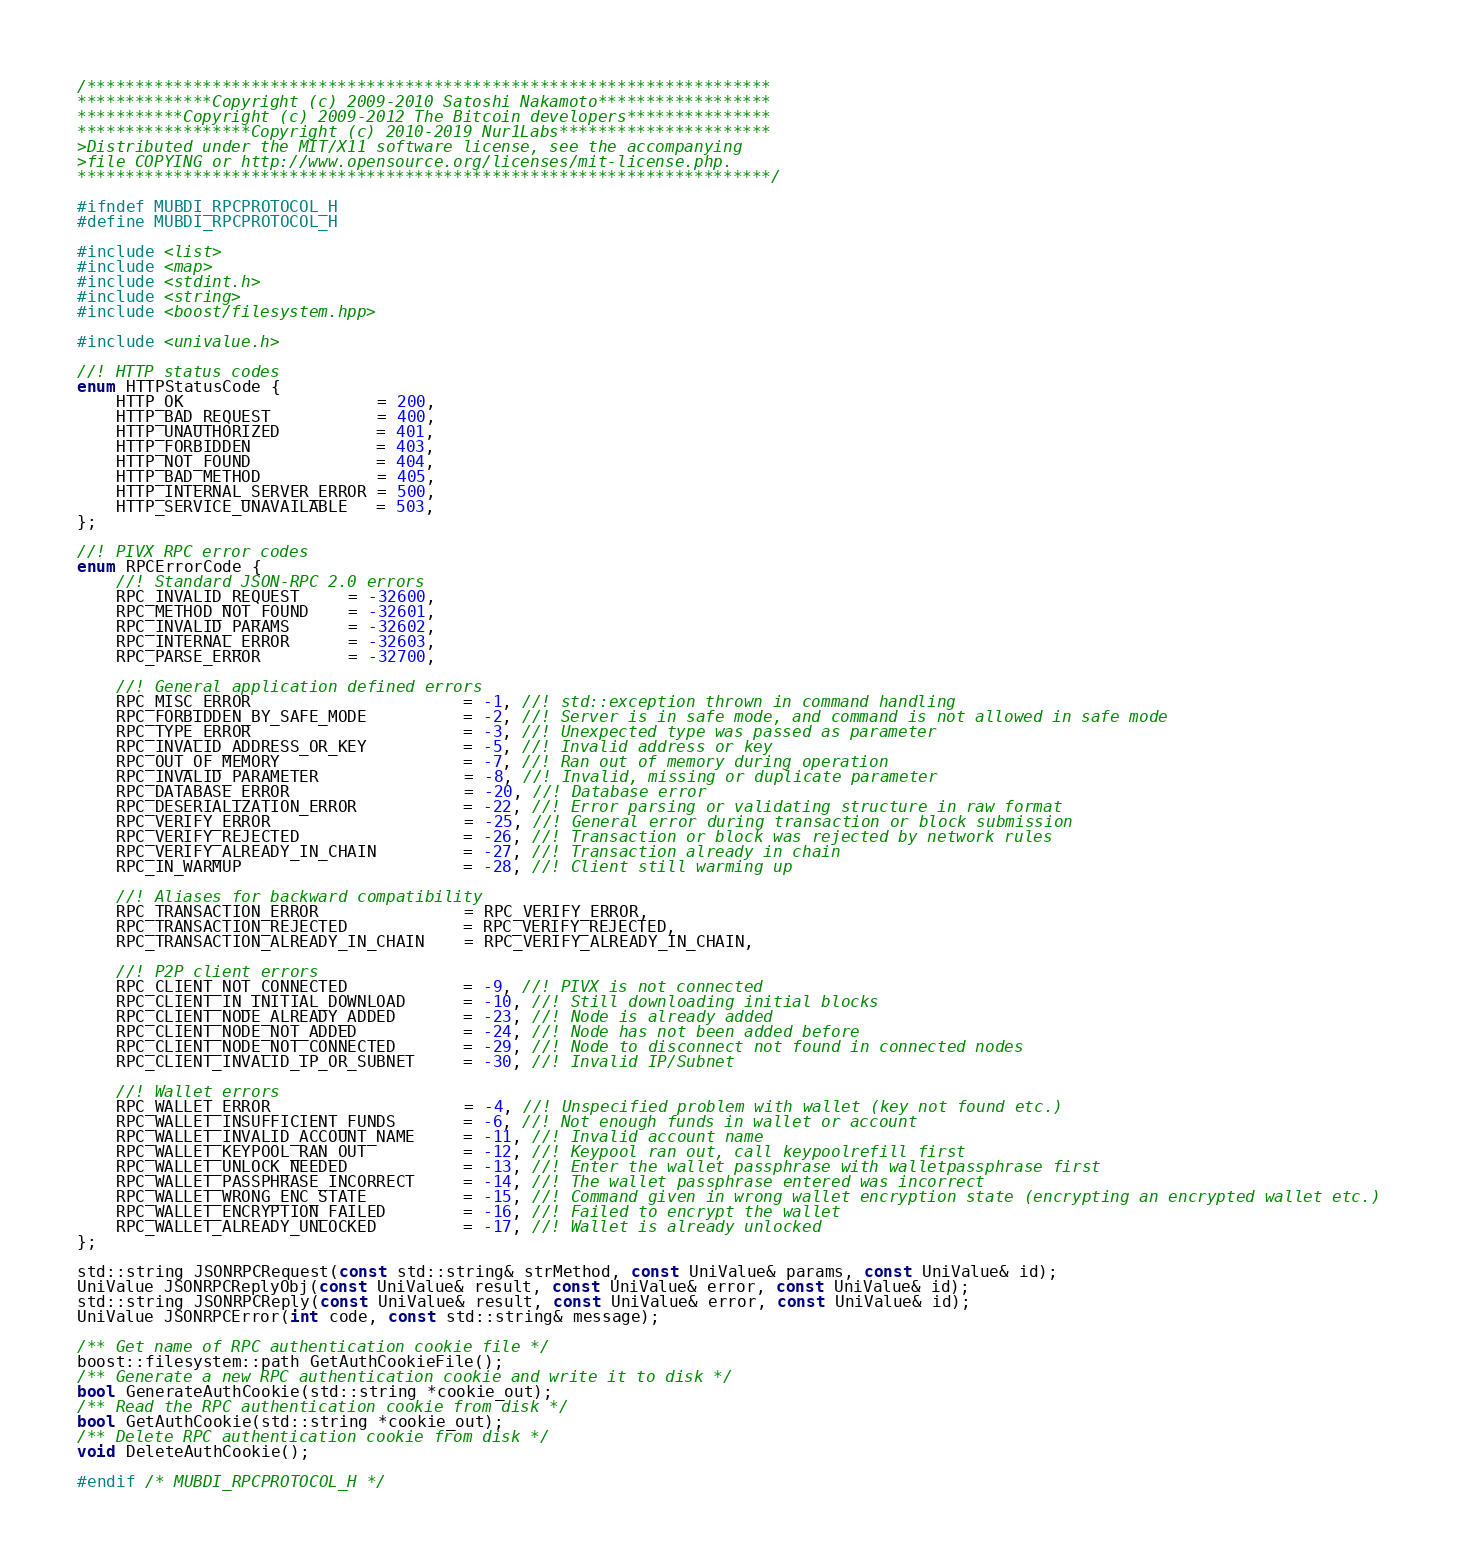<code> <loc_0><loc_0><loc_500><loc_500><_C_>/***********************************************************************
**************Copyright (c) 2009-2010 Satoshi Nakamoto******************
***********Copyright (c) 2009-2012 The Bitcoin developers***************
******************Copyright (c) 2010-2019 Nur1Labs**********************
>Distributed under the MIT/X11 software license, see the accompanying
>file COPYING or http://www.opensource.org/licenses/mit-license.php.
************************************************************************/

#ifndef MUBDI_RPCPROTOCOL_H
#define MUBDI_RPCPROTOCOL_H

#include <list>
#include <map>
#include <stdint.h>
#include <string>
#include <boost/filesystem.hpp>

#include <univalue.h>

//! HTTP status codes
enum HTTPStatusCode {
    HTTP_OK                    = 200,
    HTTP_BAD_REQUEST           = 400,
    HTTP_UNAUTHORIZED          = 401,
    HTTP_FORBIDDEN             = 403,
    HTTP_NOT_FOUND             = 404,
    HTTP_BAD_METHOD            = 405,
    HTTP_INTERNAL_SERVER_ERROR = 500,
    HTTP_SERVICE_UNAVAILABLE   = 503,
};

//! PIVX RPC error codes
enum RPCErrorCode {
    //! Standard JSON-RPC 2.0 errors
    RPC_INVALID_REQUEST     = -32600,
    RPC_METHOD_NOT_FOUND    = -32601,
    RPC_INVALID_PARAMS      = -32602,
    RPC_INTERNAL_ERROR      = -32603,
    RPC_PARSE_ERROR         = -32700,

    //! General application defined errors
    RPC_MISC_ERROR                      = -1, //! std::exception thrown in command handling
    RPC_FORBIDDEN_BY_SAFE_MODE          = -2, //! Server is in safe mode, and command is not allowed in safe mode
    RPC_TYPE_ERROR                      = -3, //! Unexpected type was passed as parameter
    RPC_INVALID_ADDRESS_OR_KEY          = -5, //! Invalid address or key
    RPC_OUT_OF_MEMORY                   = -7, //! Ran out of memory during operation
    RPC_INVALID_PARAMETER               = -8, //! Invalid, missing or duplicate parameter
    RPC_DATABASE_ERROR                  = -20, //! Database error
    RPC_DESERIALIZATION_ERROR           = -22, //! Error parsing or validating structure in raw format
    RPC_VERIFY_ERROR                    = -25, //! General error during transaction or block submission
    RPC_VERIFY_REJECTED                 = -26, //! Transaction or block was rejected by network rules
    RPC_VERIFY_ALREADY_IN_CHAIN         = -27, //! Transaction already in chain
    RPC_IN_WARMUP                       = -28, //! Client still warming up

    //! Aliases for backward compatibility
    RPC_TRANSACTION_ERROR               = RPC_VERIFY_ERROR,
    RPC_TRANSACTION_REJECTED            = RPC_VERIFY_REJECTED,
    RPC_TRANSACTION_ALREADY_IN_CHAIN    = RPC_VERIFY_ALREADY_IN_CHAIN,

    //! P2P client errors
    RPC_CLIENT_NOT_CONNECTED            = -9, //! PIVX is not connected
    RPC_CLIENT_IN_INITIAL_DOWNLOAD      = -10, //! Still downloading initial blocks
    RPC_CLIENT_NODE_ALREADY_ADDED       = -23, //! Node is already added
    RPC_CLIENT_NODE_NOT_ADDED           = -24, //! Node has not been added before
    RPC_CLIENT_NODE_NOT_CONNECTED       = -29, //! Node to disconnect not found in connected nodes
    RPC_CLIENT_INVALID_IP_OR_SUBNET     = -30, //! Invalid IP/Subnet

    //! Wallet errors
    RPC_WALLET_ERROR                    = -4, //! Unspecified problem with wallet (key not found etc.)
    RPC_WALLET_INSUFFICIENT_FUNDS       = -6, //! Not enough funds in wallet or account
    RPC_WALLET_INVALID_ACCOUNT_NAME     = -11, //! Invalid account name
    RPC_WALLET_KEYPOOL_RAN_OUT          = -12, //! Keypool ran out, call keypoolrefill first
    RPC_WALLET_UNLOCK_NEEDED            = -13, //! Enter the wallet passphrase with walletpassphrase first
    RPC_WALLET_PASSPHRASE_INCORRECT     = -14, //! The wallet passphrase entered was incorrect
    RPC_WALLET_WRONG_ENC_STATE          = -15, //! Command given in wrong wallet encryption state (encrypting an encrypted wallet etc.)
    RPC_WALLET_ENCRYPTION_FAILED        = -16, //! Failed to encrypt the wallet
    RPC_WALLET_ALREADY_UNLOCKED         = -17, //! Wallet is already unlocked
};

std::string JSONRPCRequest(const std::string& strMethod, const UniValue& params, const UniValue& id);
UniValue JSONRPCReplyObj(const UniValue& result, const UniValue& error, const UniValue& id);
std::string JSONRPCReply(const UniValue& result, const UniValue& error, const UniValue& id);
UniValue JSONRPCError(int code, const std::string& message);

/** Get name of RPC authentication cookie file */
boost::filesystem::path GetAuthCookieFile();
/** Generate a new RPC authentication cookie and write it to disk */
bool GenerateAuthCookie(std::string *cookie_out);
/** Read the RPC authentication cookie from disk */
bool GetAuthCookie(std::string *cookie_out);
/** Delete RPC authentication cookie from disk */
void DeleteAuthCookie();

#endif /* MUBDI_RPCPROTOCOL_H */</code> 